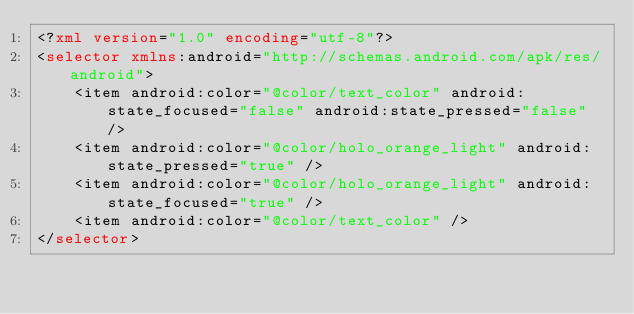Convert code to text. <code><loc_0><loc_0><loc_500><loc_500><_XML_><?xml version="1.0" encoding="utf-8"?>
<selector xmlns:android="http://schemas.android.com/apk/res/android">
    <item android:color="@color/text_color" android:state_focused="false" android:state_pressed="false" />
    <item android:color="@color/holo_orange_light" android:state_pressed="true" />
    <item android:color="@color/holo_orange_light" android:state_focused="true" />
    <item android:color="@color/text_color" />
</selector></code> 